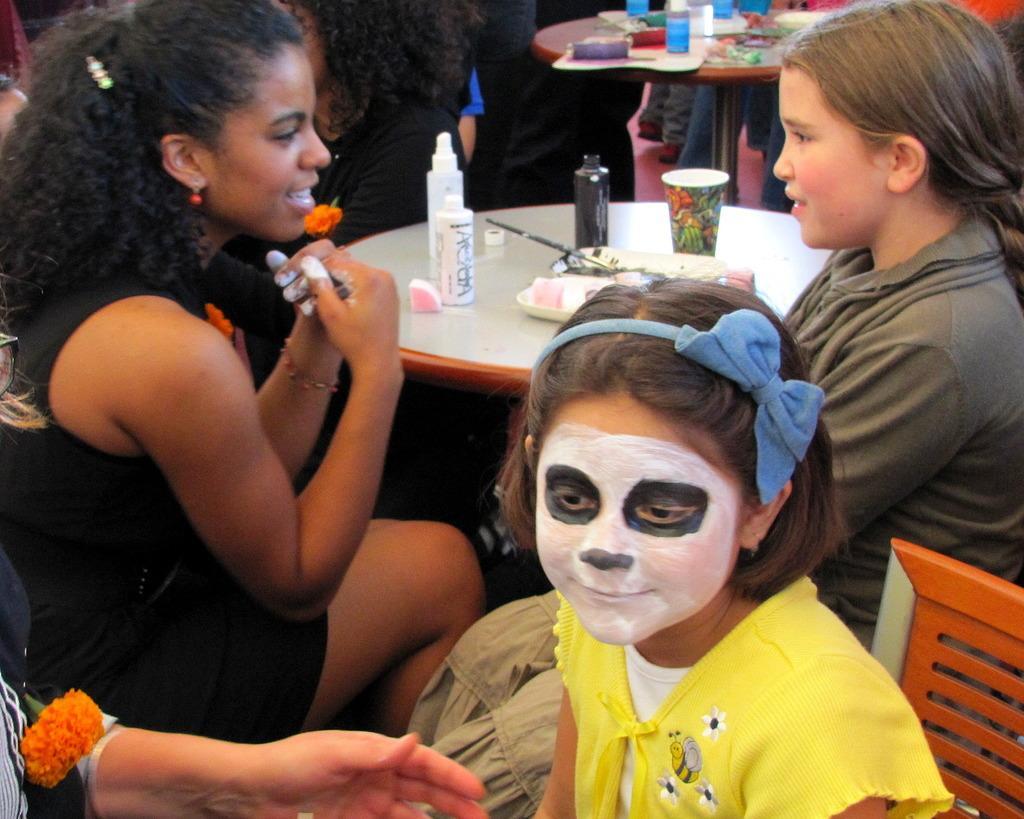How would you summarize this image in a sentence or two? In this image, I can see a small girl with a makeup is sitting on the chair. This is a table with the bottles, plate, glass and few other things on it. I can see few girls sitting. Here is another table with few objects on it. At the bottom left side of the image, I can see a person's hand. 